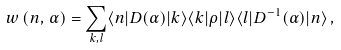<formula> <loc_0><loc_0><loc_500><loc_500>w \left ( n , \, \alpha \right ) = \sum _ { k , l } \langle n | D ( \alpha ) | k \rangle \langle k | \rho | l \rangle \langle l | D ^ { - 1 } ( \alpha ) | n \rangle \, ,</formula> 